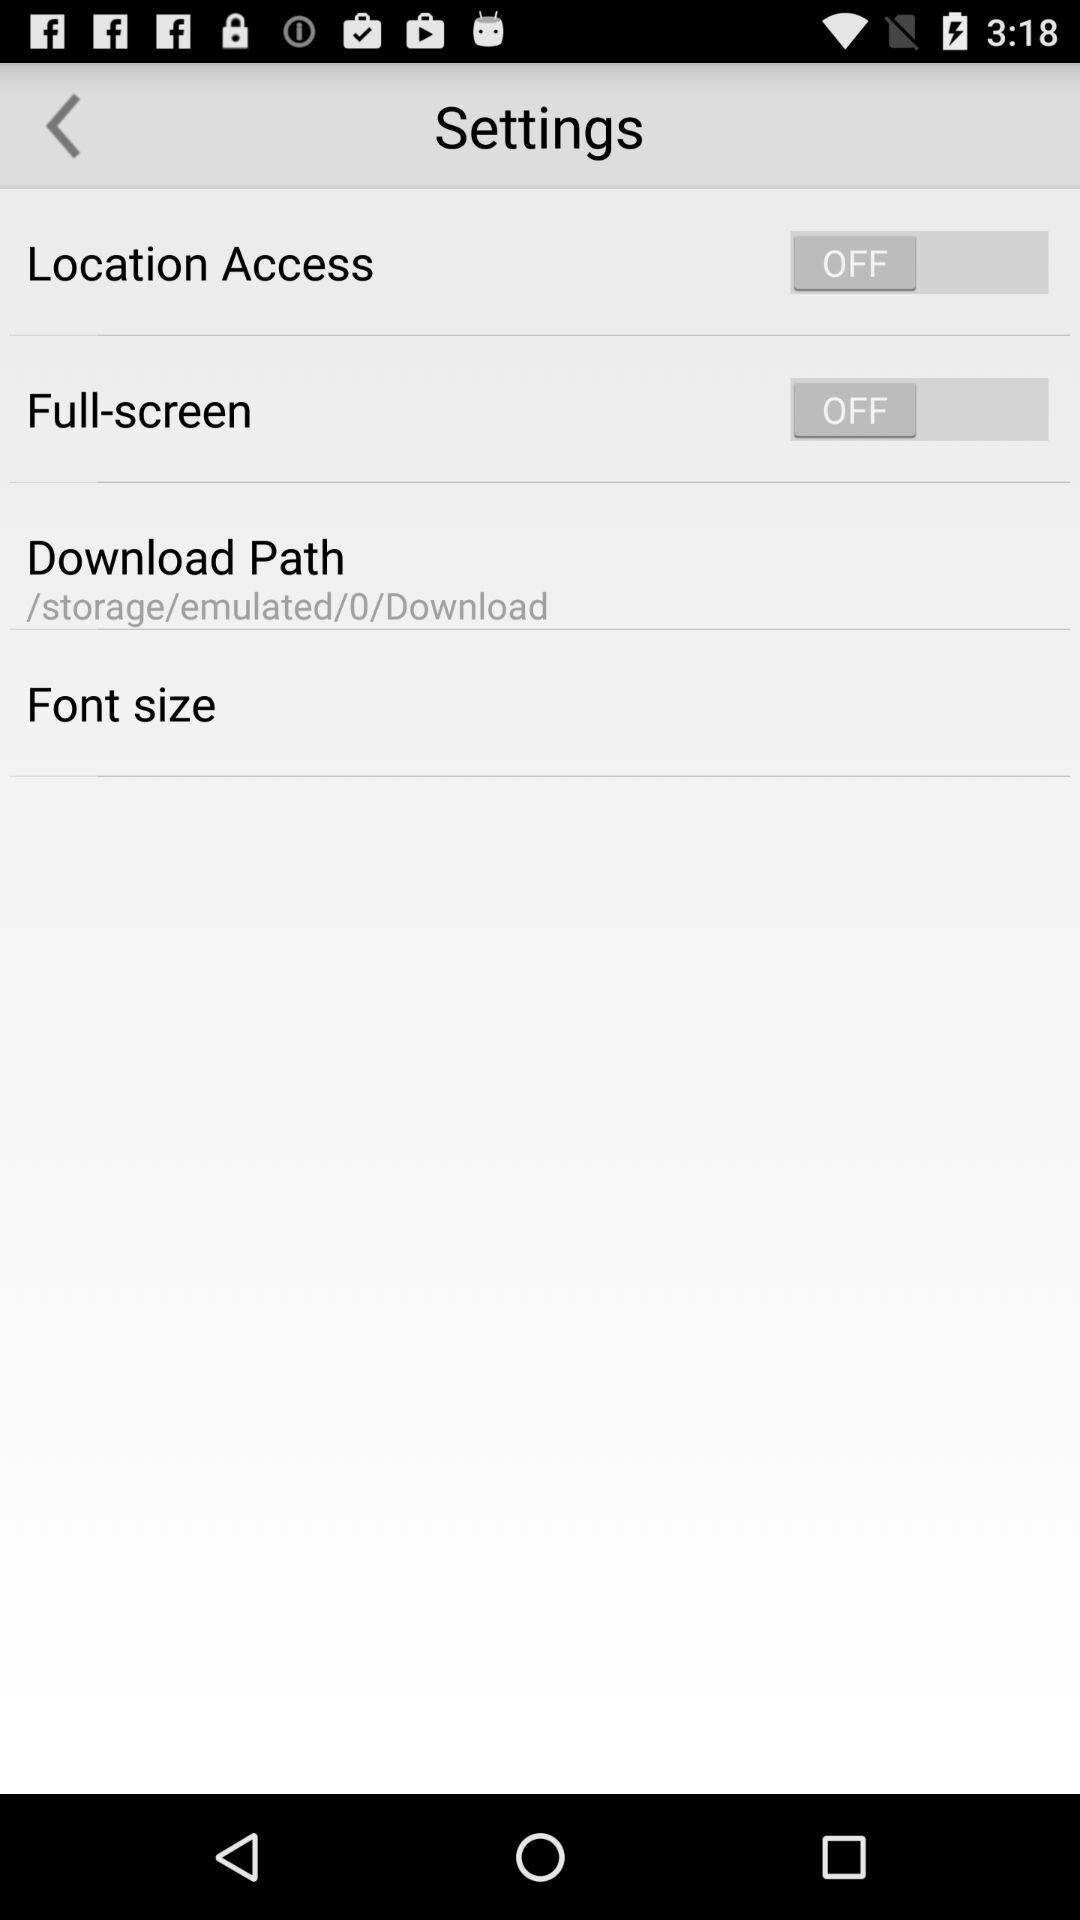What is the status of the full screen? The status is off. 